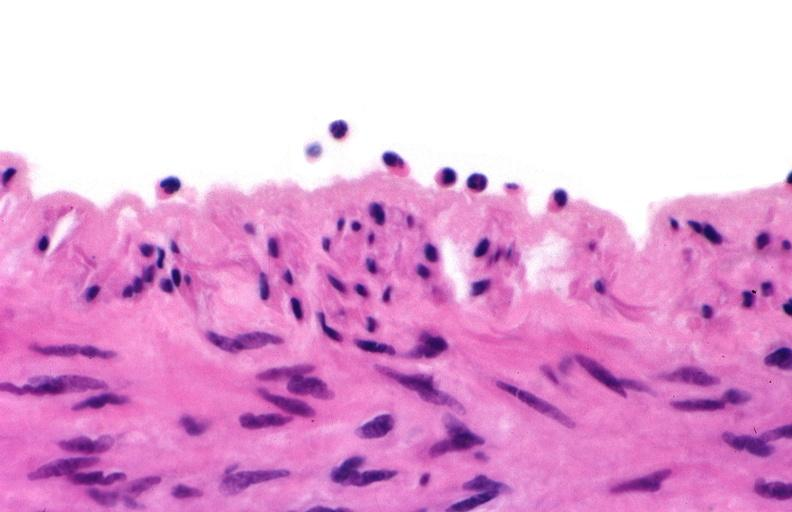s siamese twins present?
Answer the question using a single word or phrase. No 